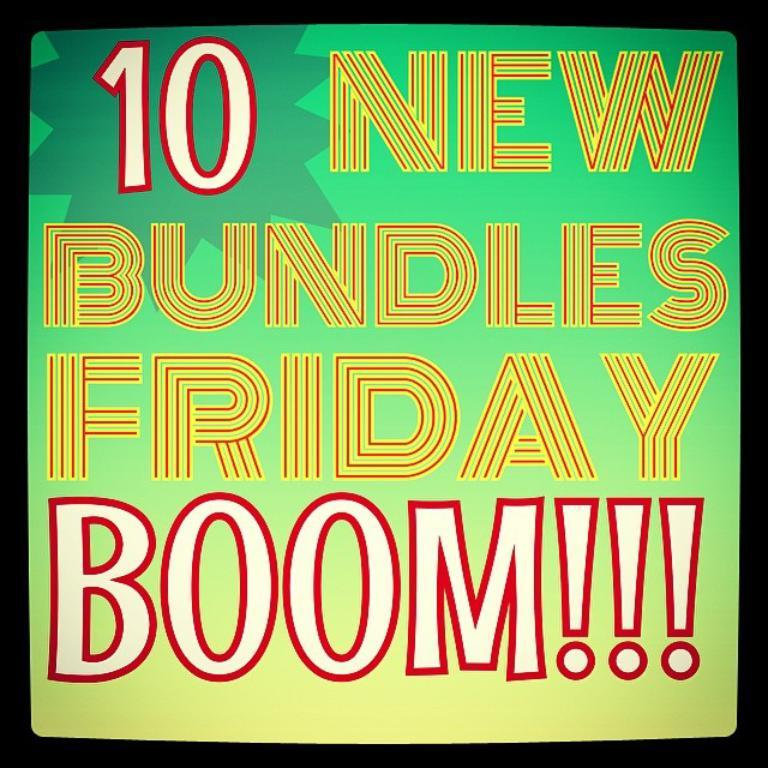<image>
Offer a succinct explanation of the picture presented. Word art that reads 10 new bundles Friday boom. 